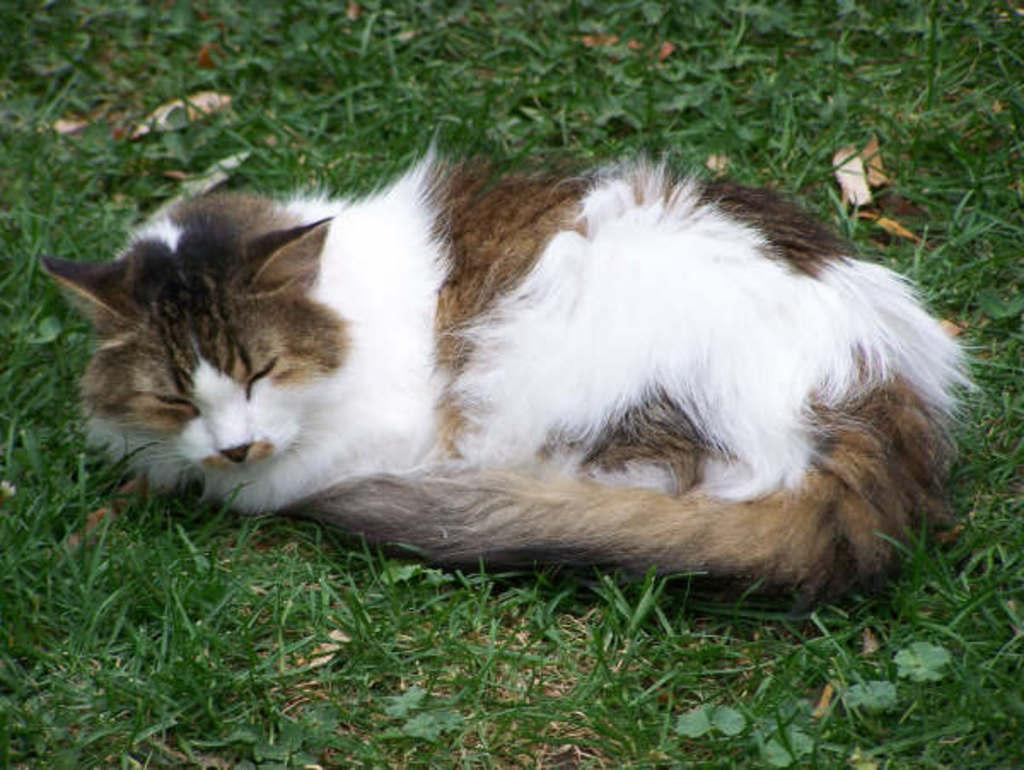What type of animal is in the image? There is a cat in the image. Can you describe the coloring of the cat? The cat has white, brown, and black coloring. Where is the cat located in the image? The cat is laying on the grass. What color is the grass in the image? The grass is green. What can be seen on the ground in the image? There are brown leaves on the ground. What position does the rail hold in the image? There is no rail present in the image. What type of pipe can be seen in the image? There is no pipe present in the image. 